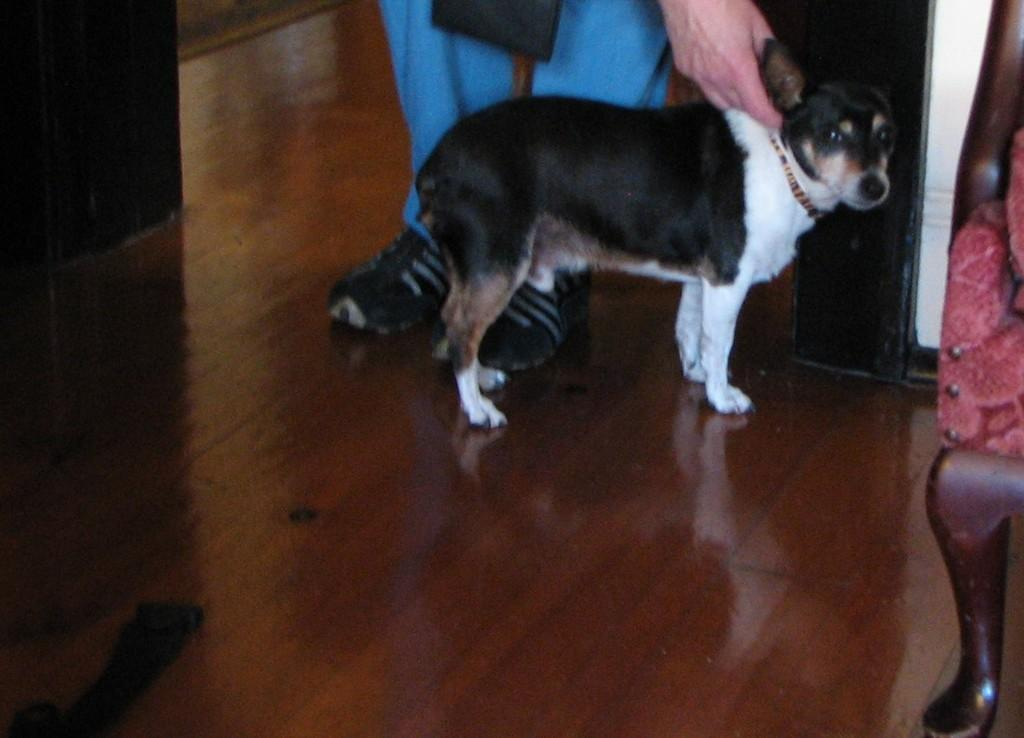Who is the main subject in the image? There is a man standing in the center of the image. What other living creature is present in the image? There is a dog in the image. What piece of furniture can be seen on the right side of the image? There is a chair on the right side of the image. What is visible at the bottom of the image? The floor is visible at the bottom of the image. Where is the zipper located on the dog in the image? There is no zipper present on the dog in the image, as dogs do not have zippers. 